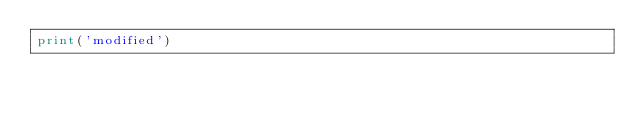Convert code to text. <code><loc_0><loc_0><loc_500><loc_500><_Python_>print('modified')
</code> 